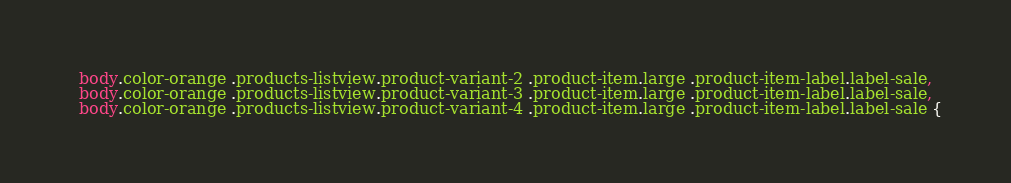Convert code to text. <code><loc_0><loc_0><loc_500><loc_500><_CSS_>  body.color-orange .products-listview.product-variant-2 .product-item.large .product-item-label.label-sale,
  body.color-orange .products-listview.product-variant-3 .product-item.large .product-item-label.label-sale,
  body.color-orange .products-listview.product-variant-4 .product-item.large .product-item-label.label-sale {</code> 